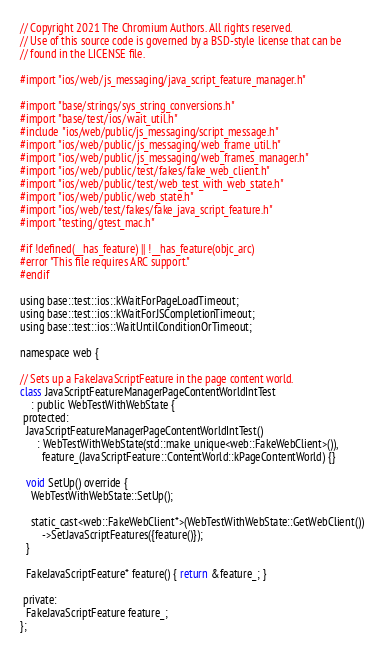Convert code to text. <code><loc_0><loc_0><loc_500><loc_500><_ObjectiveC_>// Copyright 2021 The Chromium Authors. All rights reserved.
// Use of this source code is governed by a BSD-style license that can be
// found in the LICENSE file.

#import "ios/web/js_messaging/java_script_feature_manager.h"

#import "base/strings/sys_string_conversions.h"
#import "base/test/ios/wait_util.h"
#include "ios/web/public/js_messaging/script_message.h"
#import "ios/web/public/js_messaging/web_frame_util.h"
#import "ios/web/public/js_messaging/web_frames_manager.h"
#import "ios/web/public/test/fakes/fake_web_client.h"
#import "ios/web/public/test/web_test_with_web_state.h"
#import "ios/web/public/web_state.h"
#import "ios/web/test/fakes/fake_java_script_feature.h"
#import "testing/gtest_mac.h"

#if !defined(__has_feature) || !__has_feature(objc_arc)
#error "This file requires ARC support."
#endif

using base::test::ios::kWaitForPageLoadTimeout;
using base::test::ios::kWaitForJSCompletionTimeout;
using base::test::ios::WaitUntilConditionOrTimeout;

namespace web {

// Sets up a FakeJavaScriptFeature in the page content world.
class JavaScriptFeatureManagerPageContentWorldIntTest
    : public WebTestWithWebState {
 protected:
  JavaScriptFeatureManagerPageContentWorldIntTest()
      : WebTestWithWebState(std::make_unique<web::FakeWebClient>()),
        feature_(JavaScriptFeature::ContentWorld::kPageContentWorld) {}

  void SetUp() override {
    WebTestWithWebState::SetUp();

    static_cast<web::FakeWebClient*>(WebTestWithWebState::GetWebClient())
        ->SetJavaScriptFeatures({feature()});
  }

  FakeJavaScriptFeature* feature() { return &feature_; }

 private:
  FakeJavaScriptFeature feature_;
};
</code> 